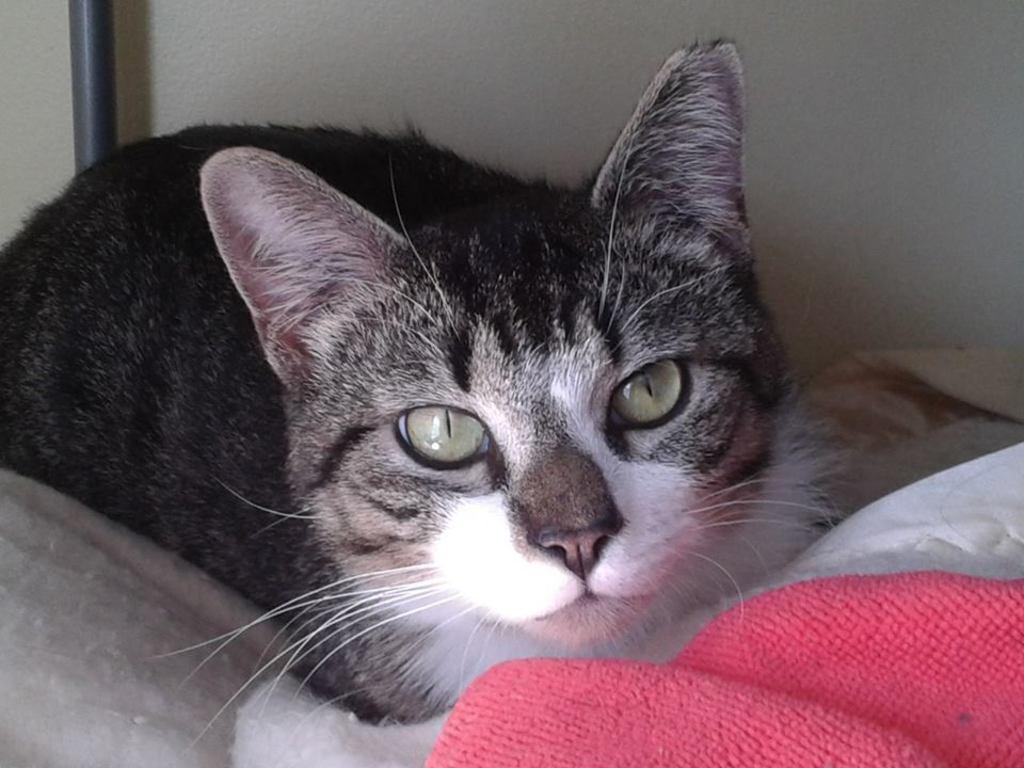What animal can be seen in the image? There is a cat in the image. What is the cat laying on? The cat is laying on a cloth. What can be seen in the background of the image? There is a wall and a rod in the background of the image. What color is the cloth at the bottom of the image? The cloth at the bottom of the image is pink. What type of insect is creating the circle in the image? There is no insect creating a circle in the image, and no insects are visible. 